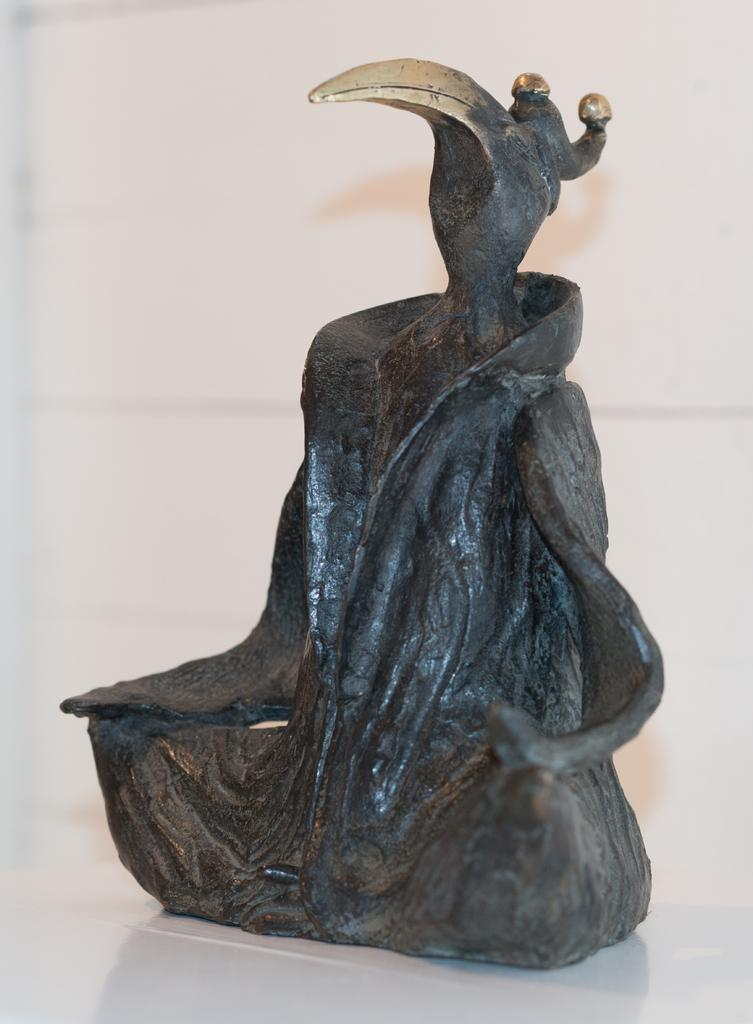What is the main subject in the center of the image? There is a sculpture in the center of the image. What type of bushes surround the sculpture in the image? There is no mention of bushes in the provided fact, so we cannot determine their presence or type in the image. 